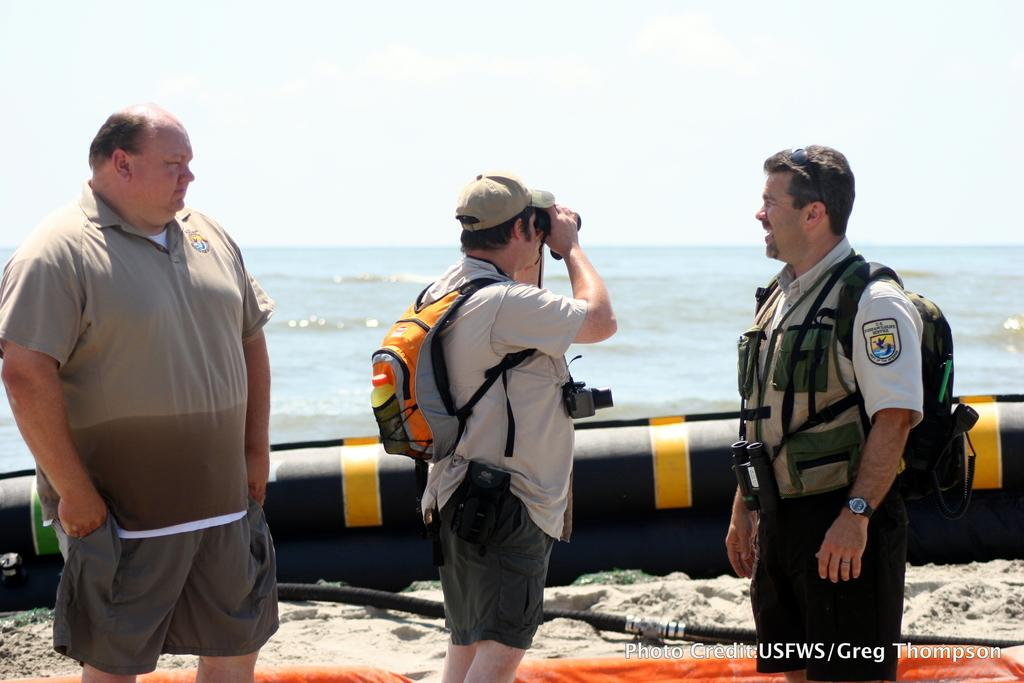How many people are in the image? There are three men in the image. What is one of the men wearing? One of the men is wearing a binocular. Who is using the binocular? Another person is using the binocular. What can be seen in the background of the image? There is a sea visible in the background of the image. What type of animals can be seen at the zoo in the image? There is no zoo present in the image, so it is not possible to determine what type of animals might be seen there. 